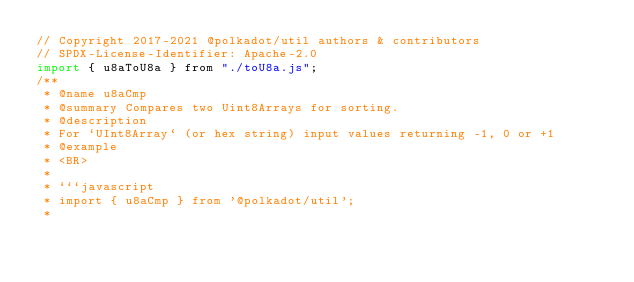Convert code to text. <code><loc_0><loc_0><loc_500><loc_500><_JavaScript_>// Copyright 2017-2021 @polkadot/util authors & contributors
// SPDX-License-Identifier: Apache-2.0
import { u8aToU8a } from "./toU8a.js";
/**
 * @name u8aCmp
 * @summary Compares two Uint8Arrays for sorting.
 * @description
 * For `UInt8Array` (or hex string) input values returning -1, 0 or +1
 * @example
 * <BR>
 *
 * ```javascript
 * import { u8aCmp } from '@polkadot/util';
 *</code> 